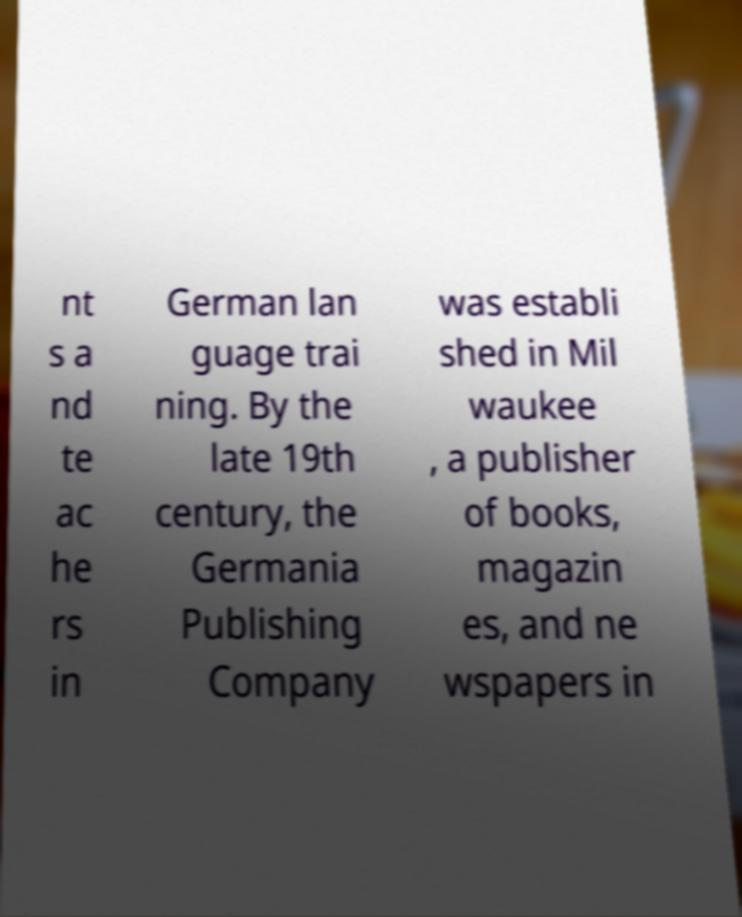Could you assist in decoding the text presented in this image and type it out clearly? nt s a nd te ac he rs in German lan guage trai ning. By the late 19th century, the Germania Publishing Company was establi shed in Mil waukee , a publisher of books, magazin es, and ne wspapers in 